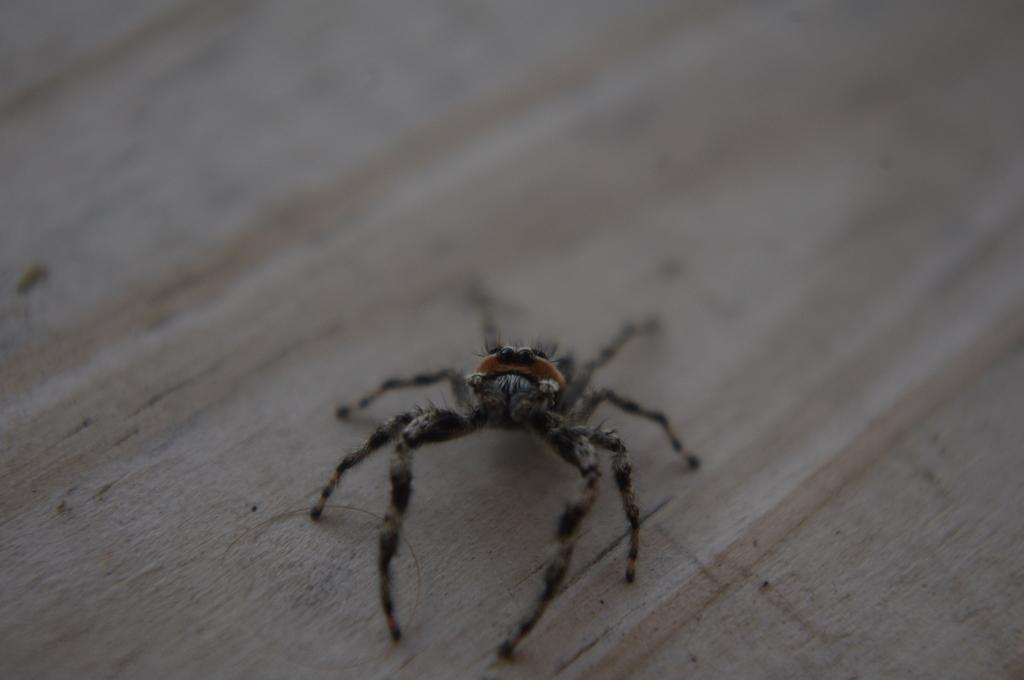What is depicted on the floor in the image? There is a spider representation on the floor in the image. What type of seed is being planted by the queen in the image? There is no queen or seed present in the image; it only features a spider representation on the floor. 